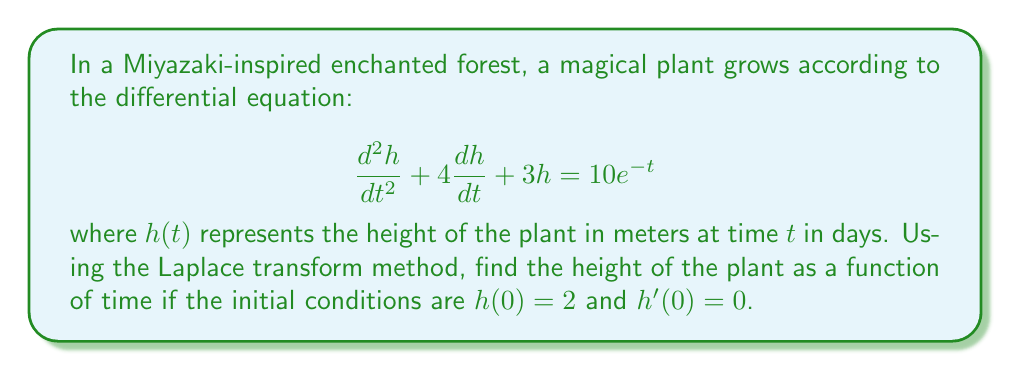Show me your answer to this math problem. Let's solve this step-by-step using the Laplace transform method:

1) First, we take the Laplace transform of both sides of the equation:

   $\mathcal{L}\{h''(t) + 4h'(t) + 3h(t)\} = \mathcal{L}\{10e^{-t}\}$

2) Using the properties of Laplace transforms:

   $[s^2H(s) - sh(0) - h'(0)] + 4[sH(s) - h(0)] + 3H(s) = \frac{10}{s+1}$

3) Substituting the initial conditions $h(0) = 2$ and $h'(0) = 0$:

   $s^2H(s) - 2s + 4sH(s) - 8 + 3H(s) = \frac{10}{s+1}$

4) Simplifying:

   $(s^2 + 4s + 3)H(s) = \frac{10}{s+1} + 2s + 8$

5) Solving for $H(s)$:

   $H(s) = \frac{10}{(s+1)(s^2+4s+3)} + \frac{2s+8}{s^2+4s+3}$

6) We can factor the denominator: $s^2+4s+3 = (s+1)(s+3)$

   $H(s) = \frac{10}{(s+1)^2(s+3)} + \frac{2s+8}{(s+1)(s+3)}$

7) Using partial fraction decomposition:

   $H(s) = \frac{A}{s+1} + \frac{B}{(s+1)^2} + \frac{C}{s+3} + \frac{D}{s+1} + \frac{E}{s+3}$

8) Solving for the coefficients (details omitted for brevity):

   $H(s) = \frac{1}{(s+1)} + \frac{5}{(s+1)^2} - \frac{1}{s+3} + \frac{2}{s+1} - \frac{2}{s+3}$

9) Taking the inverse Laplace transform:

   $h(t) = \mathcal{L}^{-1}\{H(s)\} = (1+2)e^{-t} + 5te^{-t} + (-1-2)e^{-3t}$

10) Simplifying:

    $h(t) = 3e^{-t} + 5te^{-t} - 3e^{-3t}$

This is the height of the magical plant as a function of time.
Answer: $h(t) = 3e^{-t} + 5te^{-t} - 3e^{-3t}$ 